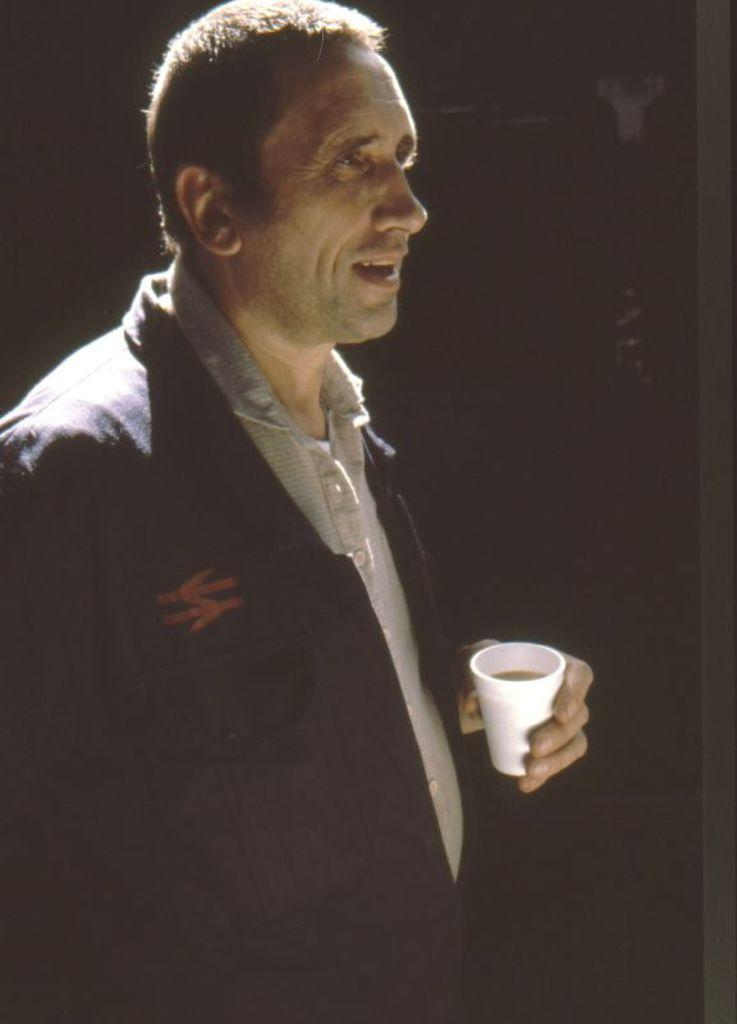What is the main subject of the image? There is a person standing in the image. What is the person holding in the image? The person is holding a cup with a drink. Can you describe the background of the image? The background of the image appears to be dark. What type of potato is being discussed by the government in the image? There is no mention of a potato or the government in the image. 